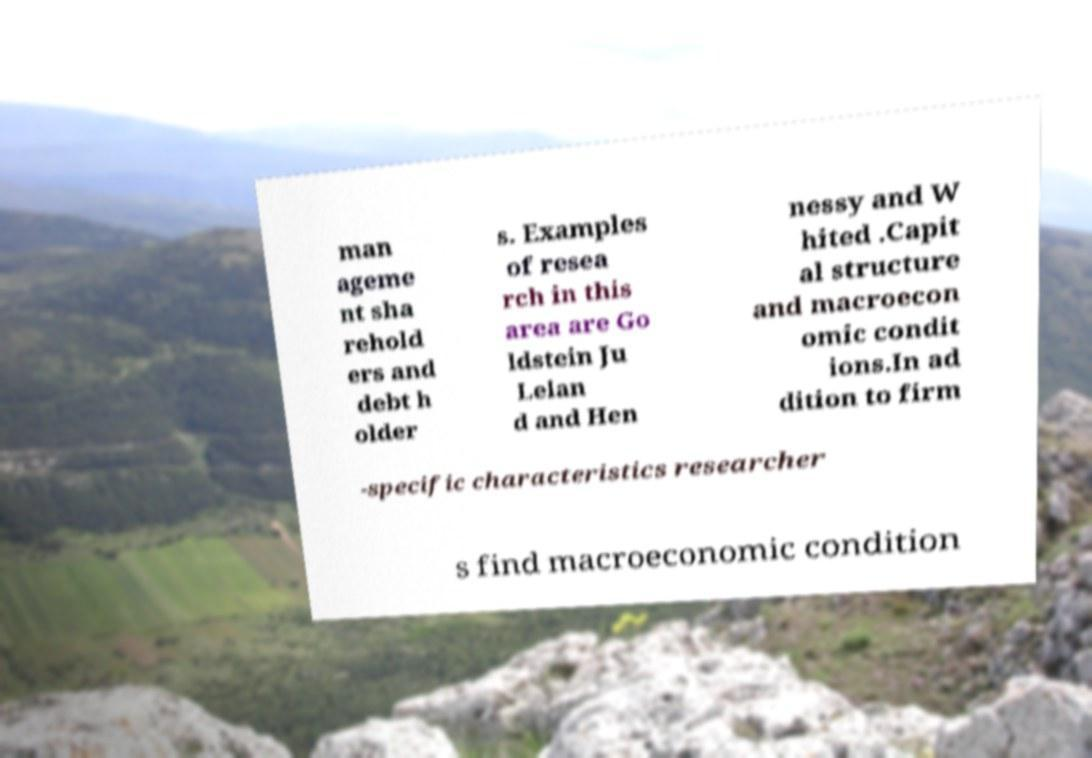Could you extract and type out the text from this image? man ageme nt sha rehold ers and debt h older s. Examples of resea rch in this area are Go ldstein Ju Lelan d and Hen nessy and W hited .Capit al structure and macroecon omic condit ions.In ad dition to firm -specific characteristics researcher s find macroeconomic condition 